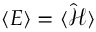Convert formula to latex. <formula><loc_0><loc_0><loc_500><loc_500>\langle E \rangle = \langle \hat { \mathcal { H } } \rangle</formula> 